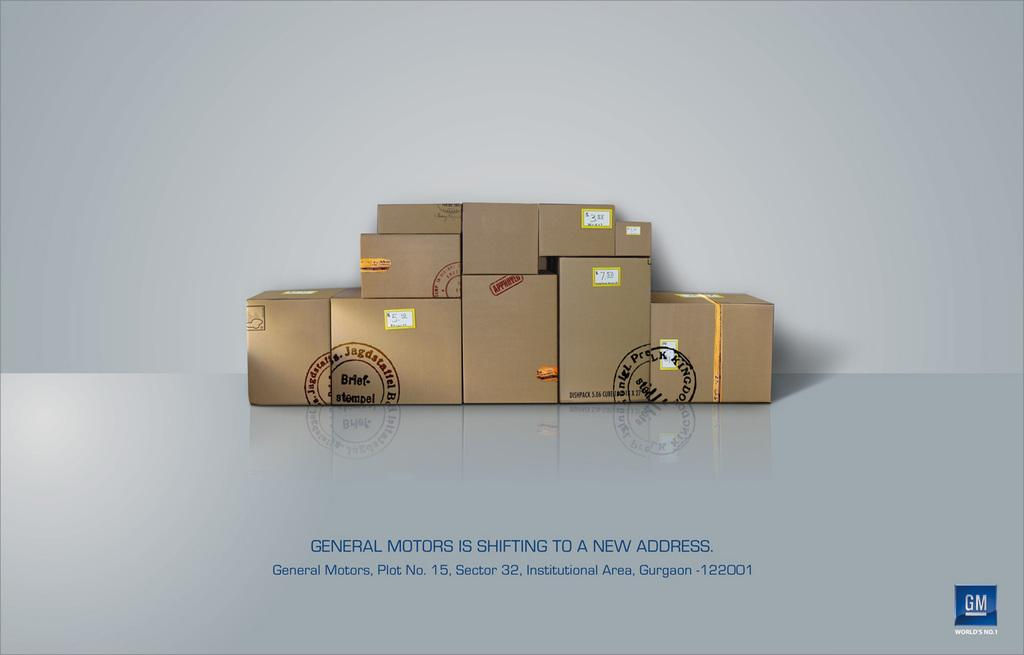<image>
Summarize the visual content of the image. Eleven brown moving boxes stacked neatly ready to move to a new address. 